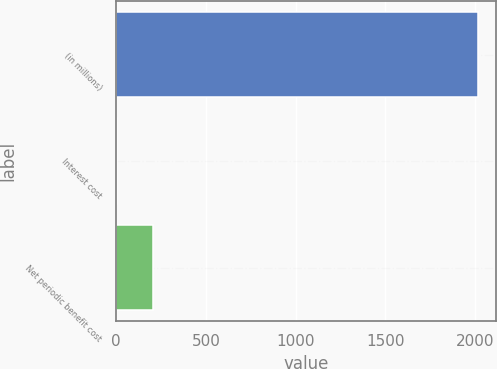Convert chart to OTSL. <chart><loc_0><loc_0><loc_500><loc_500><bar_chart><fcel>(in millions)<fcel>Interest cost<fcel>Net periodic benefit cost<nl><fcel>2017<fcel>6<fcel>207.1<nl></chart> 